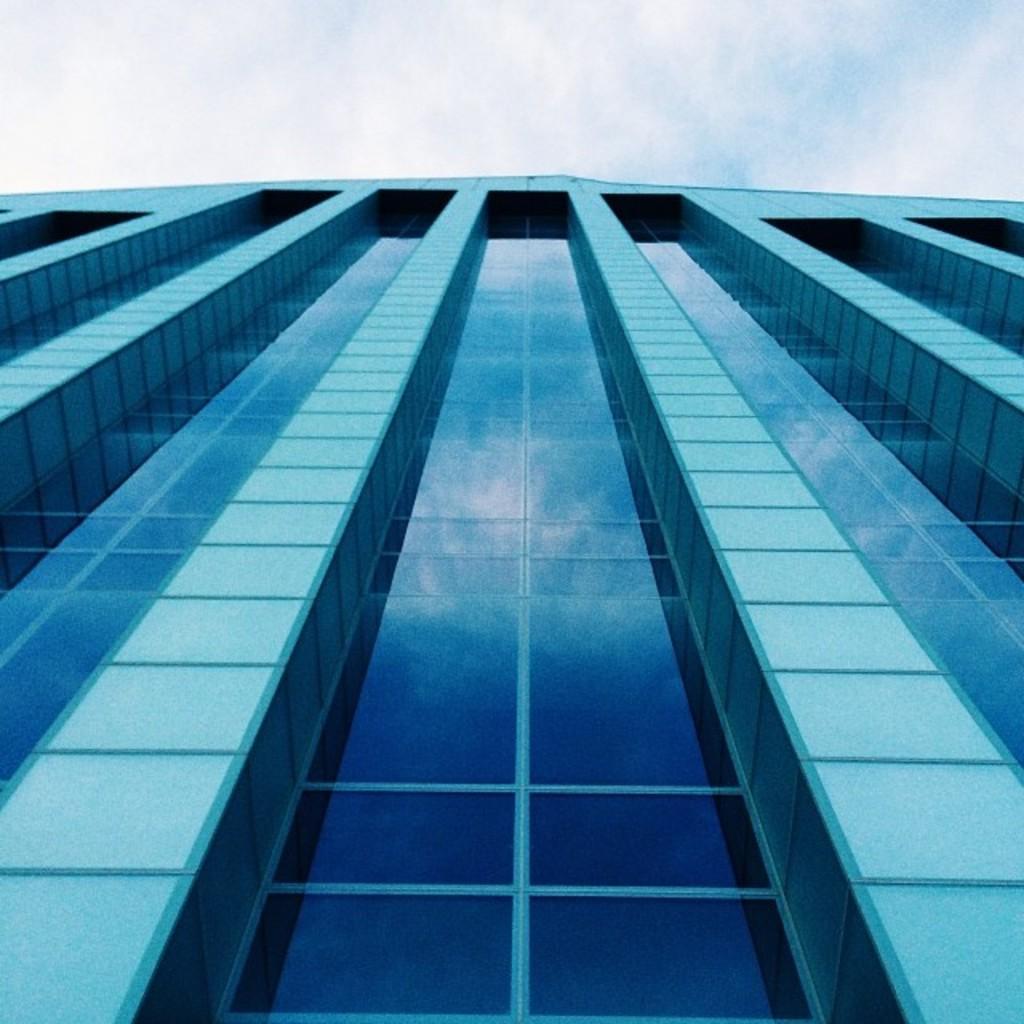How would you summarize this image in a sentence or two? In this image we can see a building. In the background, we can see the cloudy sky. 